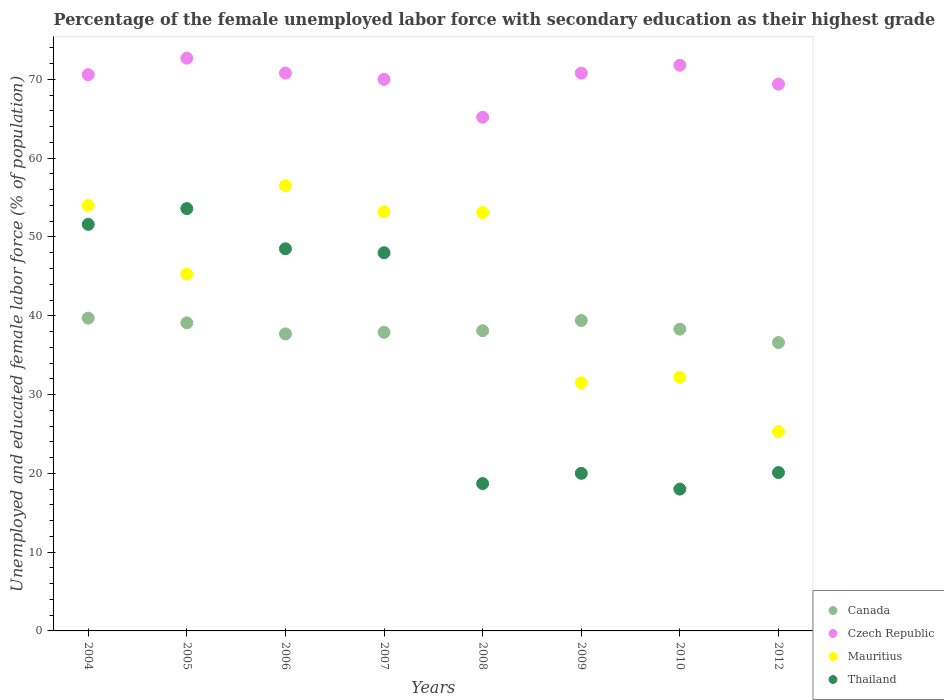How many different coloured dotlines are there?
Make the answer very short. 4. What is the percentage of the unemployed female labor force with secondary education in Canada in 2005?
Give a very brief answer. 39.1. Across all years, what is the maximum percentage of the unemployed female labor force with secondary education in Thailand?
Offer a very short reply. 53.6. Across all years, what is the minimum percentage of the unemployed female labor force with secondary education in Czech Republic?
Give a very brief answer. 65.2. What is the total percentage of the unemployed female labor force with secondary education in Czech Republic in the graph?
Keep it short and to the point. 561.3. What is the difference between the percentage of the unemployed female labor force with secondary education in Thailand in 2006 and that in 2009?
Provide a short and direct response. 28.5. What is the difference between the percentage of the unemployed female labor force with secondary education in Thailand in 2005 and the percentage of the unemployed female labor force with secondary education in Canada in 2008?
Your response must be concise. 15.5. What is the average percentage of the unemployed female labor force with secondary education in Mauritius per year?
Offer a very short reply. 43.89. In the year 2005, what is the difference between the percentage of the unemployed female labor force with secondary education in Mauritius and percentage of the unemployed female labor force with secondary education in Czech Republic?
Give a very brief answer. -27.4. In how many years, is the percentage of the unemployed female labor force with secondary education in Czech Republic greater than 66 %?
Ensure brevity in your answer.  7. What is the ratio of the percentage of the unemployed female labor force with secondary education in Czech Republic in 2004 to that in 2006?
Offer a very short reply. 1. Is the percentage of the unemployed female labor force with secondary education in Canada in 2008 less than that in 2009?
Provide a succinct answer. Yes. Is the difference between the percentage of the unemployed female labor force with secondary education in Mauritius in 2004 and 2006 greater than the difference between the percentage of the unemployed female labor force with secondary education in Czech Republic in 2004 and 2006?
Make the answer very short. No. What is the difference between the highest and the lowest percentage of the unemployed female labor force with secondary education in Czech Republic?
Provide a short and direct response. 7.5. Is it the case that in every year, the sum of the percentage of the unemployed female labor force with secondary education in Mauritius and percentage of the unemployed female labor force with secondary education in Thailand  is greater than the percentage of the unemployed female labor force with secondary education in Canada?
Ensure brevity in your answer.  Yes. Does the percentage of the unemployed female labor force with secondary education in Mauritius monotonically increase over the years?
Your answer should be very brief. No. What is the difference between two consecutive major ticks on the Y-axis?
Give a very brief answer. 10. Are the values on the major ticks of Y-axis written in scientific E-notation?
Keep it short and to the point. No. Does the graph contain any zero values?
Ensure brevity in your answer.  No. Does the graph contain grids?
Make the answer very short. No. Where does the legend appear in the graph?
Provide a succinct answer. Bottom right. How many legend labels are there?
Provide a short and direct response. 4. How are the legend labels stacked?
Offer a very short reply. Vertical. What is the title of the graph?
Ensure brevity in your answer.  Percentage of the female unemployed labor force with secondary education as their highest grade. What is the label or title of the Y-axis?
Ensure brevity in your answer.  Unemployed and educated female labor force (% of population). What is the Unemployed and educated female labor force (% of population) in Canada in 2004?
Provide a short and direct response. 39.7. What is the Unemployed and educated female labor force (% of population) of Czech Republic in 2004?
Your answer should be very brief. 70.6. What is the Unemployed and educated female labor force (% of population) in Thailand in 2004?
Your answer should be very brief. 51.6. What is the Unemployed and educated female labor force (% of population) in Canada in 2005?
Provide a short and direct response. 39.1. What is the Unemployed and educated female labor force (% of population) in Czech Republic in 2005?
Your answer should be very brief. 72.7. What is the Unemployed and educated female labor force (% of population) of Mauritius in 2005?
Offer a very short reply. 45.3. What is the Unemployed and educated female labor force (% of population) of Thailand in 2005?
Your answer should be compact. 53.6. What is the Unemployed and educated female labor force (% of population) in Canada in 2006?
Offer a very short reply. 37.7. What is the Unemployed and educated female labor force (% of population) of Czech Republic in 2006?
Make the answer very short. 70.8. What is the Unemployed and educated female labor force (% of population) of Mauritius in 2006?
Keep it short and to the point. 56.5. What is the Unemployed and educated female labor force (% of population) of Thailand in 2006?
Offer a very short reply. 48.5. What is the Unemployed and educated female labor force (% of population) of Canada in 2007?
Keep it short and to the point. 37.9. What is the Unemployed and educated female labor force (% of population) of Mauritius in 2007?
Provide a succinct answer. 53.2. What is the Unemployed and educated female labor force (% of population) of Thailand in 2007?
Keep it short and to the point. 48. What is the Unemployed and educated female labor force (% of population) in Canada in 2008?
Provide a short and direct response. 38.1. What is the Unemployed and educated female labor force (% of population) in Czech Republic in 2008?
Offer a terse response. 65.2. What is the Unemployed and educated female labor force (% of population) of Mauritius in 2008?
Ensure brevity in your answer.  53.1. What is the Unemployed and educated female labor force (% of population) in Thailand in 2008?
Ensure brevity in your answer.  18.7. What is the Unemployed and educated female labor force (% of population) in Canada in 2009?
Keep it short and to the point. 39.4. What is the Unemployed and educated female labor force (% of population) of Czech Republic in 2009?
Offer a very short reply. 70.8. What is the Unemployed and educated female labor force (% of population) of Mauritius in 2009?
Ensure brevity in your answer.  31.5. What is the Unemployed and educated female labor force (% of population) in Canada in 2010?
Provide a succinct answer. 38.3. What is the Unemployed and educated female labor force (% of population) of Czech Republic in 2010?
Make the answer very short. 71.8. What is the Unemployed and educated female labor force (% of population) of Mauritius in 2010?
Offer a terse response. 32.2. What is the Unemployed and educated female labor force (% of population) of Canada in 2012?
Your answer should be very brief. 36.6. What is the Unemployed and educated female labor force (% of population) of Czech Republic in 2012?
Ensure brevity in your answer.  69.4. What is the Unemployed and educated female labor force (% of population) in Mauritius in 2012?
Provide a short and direct response. 25.3. What is the Unemployed and educated female labor force (% of population) in Thailand in 2012?
Your answer should be compact. 20.1. Across all years, what is the maximum Unemployed and educated female labor force (% of population) of Canada?
Make the answer very short. 39.7. Across all years, what is the maximum Unemployed and educated female labor force (% of population) in Czech Republic?
Your answer should be very brief. 72.7. Across all years, what is the maximum Unemployed and educated female labor force (% of population) of Mauritius?
Offer a terse response. 56.5. Across all years, what is the maximum Unemployed and educated female labor force (% of population) of Thailand?
Your answer should be very brief. 53.6. Across all years, what is the minimum Unemployed and educated female labor force (% of population) in Canada?
Your answer should be compact. 36.6. Across all years, what is the minimum Unemployed and educated female labor force (% of population) of Czech Republic?
Provide a short and direct response. 65.2. Across all years, what is the minimum Unemployed and educated female labor force (% of population) in Mauritius?
Your response must be concise. 25.3. What is the total Unemployed and educated female labor force (% of population) of Canada in the graph?
Your answer should be compact. 306.8. What is the total Unemployed and educated female labor force (% of population) of Czech Republic in the graph?
Your answer should be very brief. 561.3. What is the total Unemployed and educated female labor force (% of population) in Mauritius in the graph?
Provide a short and direct response. 351.1. What is the total Unemployed and educated female labor force (% of population) in Thailand in the graph?
Keep it short and to the point. 278.5. What is the difference between the Unemployed and educated female labor force (% of population) in Czech Republic in 2004 and that in 2005?
Your answer should be compact. -2.1. What is the difference between the Unemployed and educated female labor force (% of population) of Mauritius in 2004 and that in 2005?
Your response must be concise. 8.7. What is the difference between the Unemployed and educated female labor force (% of population) of Canada in 2004 and that in 2006?
Ensure brevity in your answer.  2. What is the difference between the Unemployed and educated female labor force (% of population) in Mauritius in 2004 and that in 2006?
Provide a succinct answer. -2.5. What is the difference between the Unemployed and educated female labor force (% of population) in Czech Republic in 2004 and that in 2007?
Ensure brevity in your answer.  0.6. What is the difference between the Unemployed and educated female labor force (% of population) of Mauritius in 2004 and that in 2007?
Provide a succinct answer. 0.8. What is the difference between the Unemployed and educated female labor force (% of population) in Thailand in 2004 and that in 2007?
Give a very brief answer. 3.6. What is the difference between the Unemployed and educated female labor force (% of population) in Mauritius in 2004 and that in 2008?
Your answer should be very brief. 0.9. What is the difference between the Unemployed and educated female labor force (% of population) in Thailand in 2004 and that in 2008?
Make the answer very short. 32.9. What is the difference between the Unemployed and educated female labor force (% of population) in Czech Republic in 2004 and that in 2009?
Offer a very short reply. -0.2. What is the difference between the Unemployed and educated female labor force (% of population) in Mauritius in 2004 and that in 2009?
Offer a terse response. 22.5. What is the difference between the Unemployed and educated female labor force (% of population) of Thailand in 2004 and that in 2009?
Your response must be concise. 31.6. What is the difference between the Unemployed and educated female labor force (% of population) of Czech Republic in 2004 and that in 2010?
Your answer should be compact. -1.2. What is the difference between the Unemployed and educated female labor force (% of population) in Mauritius in 2004 and that in 2010?
Offer a very short reply. 21.8. What is the difference between the Unemployed and educated female labor force (% of population) of Thailand in 2004 and that in 2010?
Provide a succinct answer. 33.6. What is the difference between the Unemployed and educated female labor force (% of population) in Mauritius in 2004 and that in 2012?
Keep it short and to the point. 28.7. What is the difference between the Unemployed and educated female labor force (% of population) of Thailand in 2004 and that in 2012?
Your response must be concise. 31.5. What is the difference between the Unemployed and educated female labor force (% of population) in Canada in 2005 and that in 2006?
Your answer should be compact. 1.4. What is the difference between the Unemployed and educated female labor force (% of population) in Czech Republic in 2005 and that in 2006?
Provide a short and direct response. 1.9. What is the difference between the Unemployed and educated female labor force (% of population) of Thailand in 2005 and that in 2006?
Provide a succinct answer. 5.1. What is the difference between the Unemployed and educated female labor force (% of population) in Czech Republic in 2005 and that in 2007?
Keep it short and to the point. 2.7. What is the difference between the Unemployed and educated female labor force (% of population) in Czech Republic in 2005 and that in 2008?
Offer a terse response. 7.5. What is the difference between the Unemployed and educated female labor force (% of population) in Thailand in 2005 and that in 2008?
Make the answer very short. 34.9. What is the difference between the Unemployed and educated female labor force (% of population) of Czech Republic in 2005 and that in 2009?
Provide a succinct answer. 1.9. What is the difference between the Unemployed and educated female labor force (% of population) of Mauritius in 2005 and that in 2009?
Ensure brevity in your answer.  13.8. What is the difference between the Unemployed and educated female labor force (% of population) in Thailand in 2005 and that in 2009?
Offer a terse response. 33.6. What is the difference between the Unemployed and educated female labor force (% of population) of Czech Republic in 2005 and that in 2010?
Provide a succinct answer. 0.9. What is the difference between the Unemployed and educated female labor force (% of population) in Thailand in 2005 and that in 2010?
Provide a succinct answer. 35.6. What is the difference between the Unemployed and educated female labor force (% of population) in Czech Republic in 2005 and that in 2012?
Your answer should be very brief. 3.3. What is the difference between the Unemployed and educated female labor force (% of population) of Thailand in 2005 and that in 2012?
Offer a very short reply. 33.5. What is the difference between the Unemployed and educated female labor force (% of population) of Canada in 2006 and that in 2007?
Your answer should be compact. -0.2. What is the difference between the Unemployed and educated female labor force (% of population) of Thailand in 2006 and that in 2007?
Give a very brief answer. 0.5. What is the difference between the Unemployed and educated female labor force (% of population) in Thailand in 2006 and that in 2008?
Ensure brevity in your answer.  29.8. What is the difference between the Unemployed and educated female labor force (% of population) in Canada in 2006 and that in 2009?
Your answer should be compact. -1.7. What is the difference between the Unemployed and educated female labor force (% of population) in Mauritius in 2006 and that in 2009?
Provide a succinct answer. 25. What is the difference between the Unemployed and educated female labor force (% of population) in Czech Republic in 2006 and that in 2010?
Offer a terse response. -1. What is the difference between the Unemployed and educated female labor force (% of population) in Mauritius in 2006 and that in 2010?
Your answer should be very brief. 24.3. What is the difference between the Unemployed and educated female labor force (% of population) of Thailand in 2006 and that in 2010?
Make the answer very short. 30.5. What is the difference between the Unemployed and educated female labor force (% of population) in Canada in 2006 and that in 2012?
Offer a terse response. 1.1. What is the difference between the Unemployed and educated female labor force (% of population) of Mauritius in 2006 and that in 2012?
Provide a succinct answer. 31.2. What is the difference between the Unemployed and educated female labor force (% of population) in Thailand in 2006 and that in 2012?
Offer a very short reply. 28.4. What is the difference between the Unemployed and educated female labor force (% of population) in Czech Republic in 2007 and that in 2008?
Keep it short and to the point. 4.8. What is the difference between the Unemployed and educated female labor force (% of population) of Thailand in 2007 and that in 2008?
Offer a very short reply. 29.3. What is the difference between the Unemployed and educated female labor force (% of population) of Czech Republic in 2007 and that in 2009?
Give a very brief answer. -0.8. What is the difference between the Unemployed and educated female labor force (% of population) of Mauritius in 2007 and that in 2009?
Offer a very short reply. 21.7. What is the difference between the Unemployed and educated female labor force (% of population) of Thailand in 2007 and that in 2009?
Ensure brevity in your answer.  28. What is the difference between the Unemployed and educated female labor force (% of population) in Czech Republic in 2007 and that in 2010?
Your answer should be very brief. -1.8. What is the difference between the Unemployed and educated female labor force (% of population) in Mauritius in 2007 and that in 2010?
Offer a terse response. 21. What is the difference between the Unemployed and educated female labor force (% of population) of Canada in 2007 and that in 2012?
Your response must be concise. 1.3. What is the difference between the Unemployed and educated female labor force (% of population) of Mauritius in 2007 and that in 2012?
Your answer should be compact. 27.9. What is the difference between the Unemployed and educated female labor force (% of population) of Thailand in 2007 and that in 2012?
Make the answer very short. 27.9. What is the difference between the Unemployed and educated female labor force (% of population) in Mauritius in 2008 and that in 2009?
Provide a succinct answer. 21.6. What is the difference between the Unemployed and educated female labor force (% of population) in Thailand in 2008 and that in 2009?
Your answer should be compact. -1.3. What is the difference between the Unemployed and educated female labor force (% of population) in Canada in 2008 and that in 2010?
Ensure brevity in your answer.  -0.2. What is the difference between the Unemployed and educated female labor force (% of population) in Mauritius in 2008 and that in 2010?
Ensure brevity in your answer.  20.9. What is the difference between the Unemployed and educated female labor force (% of population) of Thailand in 2008 and that in 2010?
Ensure brevity in your answer.  0.7. What is the difference between the Unemployed and educated female labor force (% of population) of Czech Republic in 2008 and that in 2012?
Offer a terse response. -4.2. What is the difference between the Unemployed and educated female labor force (% of population) of Mauritius in 2008 and that in 2012?
Make the answer very short. 27.8. What is the difference between the Unemployed and educated female labor force (% of population) of Thailand in 2008 and that in 2012?
Offer a terse response. -1.4. What is the difference between the Unemployed and educated female labor force (% of population) of Czech Republic in 2009 and that in 2010?
Make the answer very short. -1. What is the difference between the Unemployed and educated female labor force (% of population) of Thailand in 2009 and that in 2010?
Provide a succinct answer. 2. What is the difference between the Unemployed and educated female labor force (% of population) of Czech Republic in 2010 and that in 2012?
Ensure brevity in your answer.  2.4. What is the difference between the Unemployed and educated female labor force (% of population) of Canada in 2004 and the Unemployed and educated female labor force (% of population) of Czech Republic in 2005?
Your answer should be very brief. -33. What is the difference between the Unemployed and educated female labor force (% of population) of Canada in 2004 and the Unemployed and educated female labor force (% of population) of Mauritius in 2005?
Keep it short and to the point. -5.6. What is the difference between the Unemployed and educated female labor force (% of population) of Canada in 2004 and the Unemployed and educated female labor force (% of population) of Thailand in 2005?
Provide a succinct answer. -13.9. What is the difference between the Unemployed and educated female labor force (% of population) of Czech Republic in 2004 and the Unemployed and educated female labor force (% of population) of Mauritius in 2005?
Give a very brief answer. 25.3. What is the difference between the Unemployed and educated female labor force (% of population) in Czech Republic in 2004 and the Unemployed and educated female labor force (% of population) in Thailand in 2005?
Give a very brief answer. 17. What is the difference between the Unemployed and educated female labor force (% of population) of Mauritius in 2004 and the Unemployed and educated female labor force (% of population) of Thailand in 2005?
Your response must be concise. 0.4. What is the difference between the Unemployed and educated female labor force (% of population) in Canada in 2004 and the Unemployed and educated female labor force (% of population) in Czech Republic in 2006?
Offer a very short reply. -31.1. What is the difference between the Unemployed and educated female labor force (% of population) in Canada in 2004 and the Unemployed and educated female labor force (% of population) in Mauritius in 2006?
Your answer should be compact. -16.8. What is the difference between the Unemployed and educated female labor force (% of population) of Czech Republic in 2004 and the Unemployed and educated female labor force (% of population) of Thailand in 2006?
Give a very brief answer. 22.1. What is the difference between the Unemployed and educated female labor force (% of population) in Canada in 2004 and the Unemployed and educated female labor force (% of population) in Czech Republic in 2007?
Your answer should be very brief. -30.3. What is the difference between the Unemployed and educated female labor force (% of population) in Canada in 2004 and the Unemployed and educated female labor force (% of population) in Mauritius in 2007?
Give a very brief answer. -13.5. What is the difference between the Unemployed and educated female labor force (% of population) in Canada in 2004 and the Unemployed and educated female labor force (% of population) in Thailand in 2007?
Your answer should be compact. -8.3. What is the difference between the Unemployed and educated female labor force (% of population) in Czech Republic in 2004 and the Unemployed and educated female labor force (% of population) in Thailand in 2007?
Make the answer very short. 22.6. What is the difference between the Unemployed and educated female labor force (% of population) in Mauritius in 2004 and the Unemployed and educated female labor force (% of population) in Thailand in 2007?
Offer a very short reply. 6. What is the difference between the Unemployed and educated female labor force (% of population) in Canada in 2004 and the Unemployed and educated female labor force (% of population) in Czech Republic in 2008?
Offer a very short reply. -25.5. What is the difference between the Unemployed and educated female labor force (% of population) of Canada in 2004 and the Unemployed and educated female labor force (% of population) of Mauritius in 2008?
Your answer should be compact. -13.4. What is the difference between the Unemployed and educated female labor force (% of population) in Czech Republic in 2004 and the Unemployed and educated female labor force (% of population) in Mauritius in 2008?
Your answer should be very brief. 17.5. What is the difference between the Unemployed and educated female labor force (% of population) of Czech Republic in 2004 and the Unemployed and educated female labor force (% of population) of Thailand in 2008?
Offer a very short reply. 51.9. What is the difference between the Unemployed and educated female labor force (% of population) in Mauritius in 2004 and the Unemployed and educated female labor force (% of population) in Thailand in 2008?
Your response must be concise. 35.3. What is the difference between the Unemployed and educated female labor force (% of population) in Canada in 2004 and the Unemployed and educated female labor force (% of population) in Czech Republic in 2009?
Provide a succinct answer. -31.1. What is the difference between the Unemployed and educated female labor force (% of population) in Canada in 2004 and the Unemployed and educated female labor force (% of population) in Mauritius in 2009?
Your answer should be compact. 8.2. What is the difference between the Unemployed and educated female labor force (% of population) in Czech Republic in 2004 and the Unemployed and educated female labor force (% of population) in Mauritius in 2009?
Give a very brief answer. 39.1. What is the difference between the Unemployed and educated female labor force (% of population) in Czech Republic in 2004 and the Unemployed and educated female labor force (% of population) in Thailand in 2009?
Your response must be concise. 50.6. What is the difference between the Unemployed and educated female labor force (% of population) in Mauritius in 2004 and the Unemployed and educated female labor force (% of population) in Thailand in 2009?
Make the answer very short. 34. What is the difference between the Unemployed and educated female labor force (% of population) of Canada in 2004 and the Unemployed and educated female labor force (% of population) of Czech Republic in 2010?
Provide a short and direct response. -32.1. What is the difference between the Unemployed and educated female labor force (% of population) of Canada in 2004 and the Unemployed and educated female labor force (% of population) of Thailand in 2010?
Ensure brevity in your answer.  21.7. What is the difference between the Unemployed and educated female labor force (% of population) of Czech Republic in 2004 and the Unemployed and educated female labor force (% of population) of Mauritius in 2010?
Your answer should be very brief. 38.4. What is the difference between the Unemployed and educated female labor force (% of population) in Czech Republic in 2004 and the Unemployed and educated female labor force (% of population) in Thailand in 2010?
Provide a succinct answer. 52.6. What is the difference between the Unemployed and educated female labor force (% of population) of Mauritius in 2004 and the Unemployed and educated female labor force (% of population) of Thailand in 2010?
Ensure brevity in your answer.  36. What is the difference between the Unemployed and educated female labor force (% of population) of Canada in 2004 and the Unemployed and educated female labor force (% of population) of Czech Republic in 2012?
Your answer should be compact. -29.7. What is the difference between the Unemployed and educated female labor force (% of population) in Canada in 2004 and the Unemployed and educated female labor force (% of population) in Thailand in 2012?
Give a very brief answer. 19.6. What is the difference between the Unemployed and educated female labor force (% of population) of Czech Republic in 2004 and the Unemployed and educated female labor force (% of population) of Mauritius in 2012?
Your answer should be very brief. 45.3. What is the difference between the Unemployed and educated female labor force (% of population) of Czech Republic in 2004 and the Unemployed and educated female labor force (% of population) of Thailand in 2012?
Provide a short and direct response. 50.5. What is the difference between the Unemployed and educated female labor force (% of population) in Mauritius in 2004 and the Unemployed and educated female labor force (% of population) in Thailand in 2012?
Offer a very short reply. 33.9. What is the difference between the Unemployed and educated female labor force (% of population) of Canada in 2005 and the Unemployed and educated female labor force (% of population) of Czech Republic in 2006?
Offer a terse response. -31.7. What is the difference between the Unemployed and educated female labor force (% of population) of Canada in 2005 and the Unemployed and educated female labor force (% of population) of Mauritius in 2006?
Give a very brief answer. -17.4. What is the difference between the Unemployed and educated female labor force (% of population) in Canada in 2005 and the Unemployed and educated female labor force (% of population) in Thailand in 2006?
Give a very brief answer. -9.4. What is the difference between the Unemployed and educated female labor force (% of population) in Czech Republic in 2005 and the Unemployed and educated female labor force (% of population) in Thailand in 2006?
Your answer should be very brief. 24.2. What is the difference between the Unemployed and educated female labor force (% of population) in Mauritius in 2005 and the Unemployed and educated female labor force (% of population) in Thailand in 2006?
Offer a terse response. -3.2. What is the difference between the Unemployed and educated female labor force (% of population) in Canada in 2005 and the Unemployed and educated female labor force (% of population) in Czech Republic in 2007?
Keep it short and to the point. -30.9. What is the difference between the Unemployed and educated female labor force (% of population) of Canada in 2005 and the Unemployed and educated female labor force (% of population) of Mauritius in 2007?
Offer a very short reply. -14.1. What is the difference between the Unemployed and educated female labor force (% of population) of Canada in 2005 and the Unemployed and educated female labor force (% of population) of Thailand in 2007?
Your answer should be compact. -8.9. What is the difference between the Unemployed and educated female labor force (% of population) of Czech Republic in 2005 and the Unemployed and educated female labor force (% of population) of Mauritius in 2007?
Give a very brief answer. 19.5. What is the difference between the Unemployed and educated female labor force (% of population) in Czech Republic in 2005 and the Unemployed and educated female labor force (% of population) in Thailand in 2007?
Make the answer very short. 24.7. What is the difference between the Unemployed and educated female labor force (% of population) in Canada in 2005 and the Unemployed and educated female labor force (% of population) in Czech Republic in 2008?
Give a very brief answer. -26.1. What is the difference between the Unemployed and educated female labor force (% of population) of Canada in 2005 and the Unemployed and educated female labor force (% of population) of Thailand in 2008?
Offer a terse response. 20.4. What is the difference between the Unemployed and educated female labor force (% of population) of Czech Republic in 2005 and the Unemployed and educated female labor force (% of population) of Mauritius in 2008?
Your answer should be very brief. 19.6. What is the difference between the Unemployed and educated female labor force (% of population) of Czech Republic in 2005 and the Unemployed and educated female labor force (% of population) of Thailand in 2008?
Keep it short and to the point. 54. What is the difference between the Unemployed and educated female labor force (% of population) of Mauritius in 2005 and the Unemployed and educated female labor force (% of population) of Thailand in 2008?
Provide a succinct answer. 26.6. What is the difference between the Unemployed and educated female labor force (% of population) in Canada in 2005 and the Unemployed and educated female labor force (% of population) in Czech Republic in 2009?
Your answer should be very brief. -31.7. What is the difference between the Unemployed and educated female labor force (% of population) of Canada in 2005 and the Unemployed and educated female labor force (% of population) of Mauritius in 2009?
Your answer should be very brief. 7.6. What is the difference between the Unemployed and educated female labor force (% of population) in Czech Republic in 2005 and the Unemployed and educated female labor force (% of population) in Mauritius in 2009?
Your answer should be compact. 41.2. What is the difference between the Unemployed and educated female labor force (% of population) of Czech Republic in 2005 and the Unemployed and educated female labor force (% of population) of Thailand in 2009?
Your answer should be compact. 52.7. What is the difference between the Unemployed and educated female labor force (% of population) in Mauritius in 2005 and the Unemployed and educated female labor force (% of population) in Thailand in 2009?
Your answer should be very brief. 25.3. What is the difference between the Unemployed and educated female labor force (% of population) in Canada in 2005 and the Unemployed and educated female labor force (% of population) in Czech Republic in 2010?
Ensure brevity in your answer.  -32.7. What is the difference between the Unemployed and educated female labor force (% of population) of Canada in 2005 and the Unemployed and educated female labor force (% of population) of Thailand in 2010?
Give a very brief answer. 21.1. What is the difference between the Unemployed and educated female labor force (% of population) of Czech Republic in 2005 and the Unemployed and educated female labor force (% of population) of Mauritius in 2010?
Offer a very short reply. 40.5. What is the difference between the Unemployed and educated female labor force (% of population) in Czech Republic in 2005 and the Unemployed and educated female labor force (% of population) in Thailand in 2010?
Make the answer very short. 54.7. What is the difference between the Unemployed and educated female labor force (% of population) in Mauritius in 2005 and the Unemployed and educated female labor force (% of population) in Thailand in 2010?
Give a very brief answer. 27.3. What is the difference between the Unemployed and educated female labor force (% of population) of Canada in 2005 and the Unemployed and educated female labor force (% of population) of Czech Republic in 2012?
Offer a very short reply. -30.3. What is the difference between the Unemployed and educated female labor force (% of population) of Canada in 2005 and the Unemployed and educated female labor force (% of population) of Thailand in 2012?
Ensure brevity in your answer.  19. What is the difference between the Unemployed and educated female labor force (% of population) of Czech Republic in 2005 and the Unemployed and educated female labor force (% of population) of Mauritius in 2012?
Give a very brief answer. 47.4. What is the difference between the Unemployed and educated female labor force (% of population) in Czech Republic in 2005 and the Unemployed and educated female labor force (% of population) in Thailand in 2012?
Provide a short and direct response. 52.6. What is the difference between the Unemployed and educated female labor force (% of population) in Mauritius in 2005 and the Unemployed and educated female labor force (% of population) in Thailand in 2012?
Offer a terse response. 25.2. What is the difference between the Unemployed and educated female labor force (% of population) in Canada in 2006 and the Unemployed and educated female labor force (% of population) in Czech Republic in 2007?
Ensure brevity in your answer.  -32.3. What is the difference between the Unemployed and educated female labor force (% of population) in Canada in 2006 and the Unemployed and educated female labor force (% of population) in Mauritius in 2007?
Your answer should be very brief. -15.5. What is the difference between the Unemployed and educated female labor force (% of population) in Czech Republic in 2006 and the Unemployed and educated female labor force (% of population) in Thailand in 2007?
Your answer should be very brief. 22.8. What is the difference between the Unemployed and educated female labor force (% of population) of Mauritius in 2006 and the Unemployed and educated female labor force (% of population) of Thailand in 2007?
Your answer should be very brief. 8.5. What is the difference between the Unemployed and educated female labor force (% of population) in Canada in 2006 and the Unemployed and educated female labor force (% of population) in Czech Republic in 2008?
Offer a terse response. -27.5. What is the difference between the Unemployed and educated female labor force (% of population) of Canada in 2006 and the Unemployed and educated female labor force (% of population) of Mauritius in 2008?
Ensure brevity in your answer.  -15.4. What is the difference between the Unemployed and educated female labor force (% of population) in Canada in 2006 and the Unemployed and educated female labor force (% of population) in Thailand in 2008?
Offer a terse response. 19. What is the difference between the Unemployed and educated female labor force (% of population) in Czech Republic in 2006 and the Unemployed and educated female labor force (% of population) in Mauritius in 2008?
Keep it short and to the point. 17.7. What is the difference between the Unemployed and educated female labor force (% of population) in Czech Republic in 2006 and the Unemployed and educated female labor force (% of population) in Thailand in 2008?
Offer a very short reply. 52.1. What is the difference between the Unemployed and educated female labor force (% of population) of Mauritius in 2006 and the Unemployed and educated female labor force (% of population) of Thailand in 2008?
Provide a short and direct response. 37.8. What is the difference between the Unemployed and educated female labor force (% of population) of Canada in 2006 and the Unemployed and educated female labor force (% of population) of Czech Republic in 2009?
Keep it short and to the point. -33.1. What is the difference between the Unemployed and educated female labor force (% of population) in Canada in 2006 and the Unemployed and educated female labor force (% of population) in Mauritius in 2009?
Make the answer very short. 6.2. What is the difference between the Unemployed and educated female labor force (% of population) in Czech Republic in 2006 and the Unemployed and educated female labor force (% of population) in Mauritius in 2009?
Your answer should be compact. 39.3. What is the difference between the Unemployed and educated female labor force (% of population) in Czech Republic in 2006 and the Unemployed and educated female labor force (% of population) in Thailand in 2009?
Give a very brief answer. 50.8. What is the difference between the Unemployed and educated female labor force (% of population) of Mauritius in 2006 and the Unemployed and educated female labor force (% of population) of Thailand in 2009?
Offer a terse response. 36.5. What is the difference between the Unemployed and educated female labor force (% of population) of Canada in 2006 and the Unemployed and educated female labor force (% of population) of Czech Republic in 2010?
Offer a terse response. -34.1. What is the difference between the Unemployed and educated female labor force (% of population) in Canada in 2006 and the Unemployed and educated female labor force (% of population) in Mauritius in 2010?
Give a very brief answer. 5.5. What is the difference between the Unemployed and educated female labor force (% of population) of Canada in 2006 and the Unemployed and educated female labor force (% of population) of Thailand in 2010?
Your response must be concise. 19.7. What is the difference between the Unemployed and educated female labor force (% of population) in Czech Republic in 2006 and the Unemployed and educated female labor force (% of population) in Mauritius in 2010?
Offer a terse response. 38.6. What is the difference between the Unemployed and educated female labor force (% of population) in Czech Republic in 2006 and the Unemployed and educated female labor force (% of population) in Thailand in 2010?
Your response must be concise. 52.8. What is the difference between the Unemployed and educated female labor force (% of population) in Mauritius in 2006 and the Unemployed and educated female labor force (% of population) in Thailand in 2010?
Keep it short and to the point. 38.5. What is the difference between the Unemployed and educated female labor force (% of population) in Canada in 2006 and the Unemployed and educated female labor force (% of population) in Czech Republic in 2012?
Your answer should be compact. -31.7. What is the difference between the Unemployed and educated female labor force (% of population) in Canada in 2006 and the Unemployed and educated female labor force (% of population) in Thailand in 2012?
Make the answer very short. 17.6. What is the difference between the Unemployed and educated female labor force (% of population) in Czech Republic in 2006 and the Unemployed and educated female labor force (% of population) in Mauritius in 2012?
Your answer should be very brief. 45.5. What is the difference between the Unemployed and educated female labor force (% of population) in Czech Republic in 2006 and the Unemployed and educated female labor force (% of population) in Thailand in 2012?
Offer a terse response. 50.7. What is the difference between the Unemployed and educated female labor force (% of population) of Mauritius in 2006 and the Unemployed and educated female labor force (% of population) of Thailand in 2012?
Provide a short and direct response. 36.4. What is the difference between the Unemployed and educated female labor force (% of population) in Canada in 2007 and the Unemployed and educated female labor force (% of population) in Czech Republic in 2008?
Provide a succinct answer. -27.3. What is the difference between the Unemployed and educated female labor force (% of population) in Canada in 2007 and the Unemployed and educated female labor force (% of population) in Mauritius in 2008?
Your answer should be very brief. -15.2. What is the difference between the Unemployed and educated female labor force (% of population) of Czech Republic in 2007 and the Unemployed and educated female labor force (% of population) of Thailand in 2008?
Your response must be concise. 51.3. What is the difference between the Unemployed and educated female labor force (% of population) of Mauritius in 2007 and the Unemployed and educated female labor force (% of population) of Thailand in 2008?
Give a very brief answer. 34.5. What is the difference between the Unemployed and educated female labor force (% of population) in Canada in 2007 and the Unemployed and educated female labor force (% of population) in Czech Republic in 2009?
Make the answer very short. -32.9. What is the difference between the Unemployed and educated female labor force (% of population) of Canada in 2007 and the Unemployed and educated female labor force (% of population) of Mauritius in 2009?
Offer a very short reply. 6.4. What is the difference between the Unemployed and educated female labor force (% of population) of Canada in 2007 and the Unemployed and educated female labor force (% of population) of Thailand in 2009?
Provide a short and direct response. 17.9. What is the difference between the Unemployed and educated female labor force (% of population) in Czech Republic in 2007 and the Unemployed and educated female labor force (% of population) in Mauritius in 2009?
Provide a short and direct response. 38.5. What is the difference between the Unemployed and educated female labor force (% of population) of Mauritius in 2007 and the Unemployed and educated female labor force (% of population) of Thailand in 2009?
Offer a terse response. 33.2. What is the difference between the Unemployed and educated female labor force (% of population) of Canada in 2007 and the Unemployed and educated female labor force (% of population) of Czech Republic in 2010?
Keep it short and to the point. -33.9. What is the difference between the Unemployed and educated female labor force (% of population) of Canada in 2007 and the Unemployed and educated female labor force (% of population) of Thailand in 2010?
Provide a succinct answer. 19.9. What is the difference between the Unemployed and educated female labor force (% of population) of Czech Republic in 2007 and the Unemployed and educated female labor force (% of population) of Mauritius in 2010?
Make the answer very short. 37.8. What is the difference between the Unemployed and educated female labor force (% of population) of Czech Republic in 2007 and the Unemployed and educated female labor force (% of population) of Thailand in 2010?
Offer a very short reply. 52. What is the difference between the Unemployed and educated female labor force (% of population) in Mauritius in 2007 and the Unemployed and educated female labor force (% of population) in Thailand in 2010?
Your answer should be compact. 35.2. What is the difference between the Unemployed and educated female labor force (% of population) of Canada in 2007 and the Unemployed and educated female labor force (% of population) of Czech Republic in 2012?
Keep it short and to the point. -31.5. What is the difference between the Unemployed and educated female labor force (% of population) of Czech Republic in 2007 and the Unemployed and educated female labor force (% of population) of Mauritius in 2012?
Offer a terse response. 44.7. What is the difference between the Unemployed and educated female labor force (% of population) of Czech Republic in 2007 and the Unemployed and educated female labor force (% of population) of Thailand in 2012?
Provide a short and direct response. 49.9. What is the difference between the Unemployed and educated female labor force (% of population) of Mauritius in 2007 and the Unemployed and educated female labor force (% of population) of Thailand in 2012?
Keep it short and to the point. 33.1. What is the difference between the Unemployed and educated female labor force (% of population) of Canada in 2008 and the Unemployed and educated female labor force (% of population) of Czech Republic in 2009?
Offer a very short reply. -32.7. What is the difference between the Unemployed and educated female labor force (% of population) of Canada in 2008 and the Unemployed and educated female labor force (% of population) of Thailand in 2009?
Ensure brevity in your answer.  18.1. What is the difference between the Unemployed and educated female labor force (% of population) in Czech Republic in 2008 and the Unemployed and educated female labor force (% of population) in Mauritius in 2009?
Offer a terse response. 33.7. What is the difference between the Unemployed and educated female labor force (% of population) of Czech Republic in 2008 and the Unemployed and educated female labor force (% of population) of Thailand in 2009?
Make the answer very short. 45.2. What is the difference between the Unemployed and educated female labor force (% of population) of Mauritius in 2008 and the Unemployed and educated female labor force (% of population) of Thailand in 2009?
Offer a very short reply. 33.1. What is the difference between the Unemployed and educated female labor force (% of population) in Canada in 2008 and the Unemployed and educated female labor force (% of population) in Czech Republic in 2010?
Ensure brevity in your answer.  -33.7. What is the difference between the Unemployed and educated female labor force (% of population) of Canada in 2008 and the Unemployed and educated female labor force (% of population) of Thailand in 2010?
Your response must be concise. 20.1. What is the difference between the Unemployed and educated female labor force (% of population) in Czech Republic in 2008 and the Unemployed and educated female labor force (% of population) in Thailand in 2010?
Offer a very short reply. 47.2. What is the difference between the Unemployed and educated female labor force (% of population) in Mauritius in 2008 and the Unemployed and educated female labor force (% of population) in Thailand in 2010?
Offer a very short reply. 35.1. What is the difference between the Unemployed and educated female labor force (% of population) in Canada in 2008 and the Unemployed and educated female labor force (% of population) in Czech Republic in 2012?
Your answer should be compact. -31.3. What is the difference between the Unemployed and educated female labor force (% of population) in Canada in 2008 and the Unemployed and educated female labor force (% of population) in Thailand in 2012?
Offer a very short reply. 18. What is the difference between the Unemployed and educated female labor force (% of population) in Czech Republic in 2008 and the Unemployed and educated female labor force (% of population) in Mauritius in 2012?
Provide a short and direct response. 39.9. What is the difference between the Unemployed and educated female labor force (% of population) in Czech Republic in 2008 and the Unemployed and educated female labor force (% of population) in Thailand in 2012?
Your answer should be compact. 45.1. What is the difference between the Unemployed and educated female labor force (% of population) in Mauritius in 2008 and the Unemployed and educated female labor force (% of population) in Thailand in 2012?
Keep it short and to the point. 33. What is the difference between the Unemployed and educated female labor force (% of population) of Canada in 2009 and the Unemployed and educated female labor force (% of population) of Czech Republic in 2010?
Offer a terse response. -32.4. What is the difference between the Unemployed and educated female labor force (% of population) of Canada in 2009 and the Unemployed and educated female labor force (% of population) of Mauritius in 2010?
Provide a succinct answer. 7.2. What is the difference between the Unemployed and educated female labor force (% of population) in Canada in 2009 and the Unemployed and educated female labor force (% of population) in Thailand in 2010?
Offer a very short reply. 21.4. What is the difference between the Unemployed and educated female labor force (% of population) in Czech Republic in 2009 and the Unemployed and educated female labor force (% of population) in Mauritius in 2010?
Your response must be concise. 38.6. What is the difference between the Unemployed and educated female labor force (% of population) in Czech Republic in 2009 and the Unemployed and educated female labor force (% of population) in Thailand in 2010?
Your answer should be very brief. 52.8. What is the difference between the Unemployed and educated female labor force (% of population) in Canada in 2009 and the Unemployed and educated female labor force (% of population) in Czech Republic in 2012?
Provide a short and direct response. -30. What is the difference between the Unemployed and educated female labor force (% of population) in Canada in 2009 and the Unemployed and educated female labor force (% of population) in Thailand in 2012?
Give a very brief answer. 19.3. What is the difference between the Unemployed and educated female labor force (% of population) in Czech Republic in 2009 and the Unemployed and educated female labor force (% of population) in Mauritius in 2012?
Make the answer very short. 45.5. What is the difference between the Unemployed and educated female labor force (% of population) in Czech Republic in 2009 and the Unemployed and educated female labor force (% of population) in Thailand in 2012?
Your response must be concise. 50.7. What is the difference between the Unemployed and educated female labor force (% of population) in Mauritius in 2009 and the Unemployed and educated female labor force (% of population) in Thailand in 2012?
Make the answer very short. 11.4. What is the difference between the Unemployed and educated female labor force (% of population) of Canada in 2010 and the Unemployed and educated female labor force (% of population) of Czech Republic in 2012?
Give a very brief answer. -31.1. What is the difference between the Unemployed and educated female labor force (% of population) of Canada in 2010 and the Unemployed and educated female labor force (% of population) of Mauritius in 2012?
Your answer should be compact. 13. What is the difference between the Unemployed and educated female labor force (% of population) in Canada in 2010 and the Unemployed and educated female labor force (% of population) in Thailand in 2012?
Your answer should be compact. 18.2. What is the difference between the Unemployed and educated female labor force (% of population) of Czech Republic in 2010 and the Unemployed and educated female labor force (% of population) of Mauritius in 2012?
Offer a terse response. 46.5. What is the difference between the Unemployed and educated female labor force (% of population) of Czech Republic in 2010 and the Unemployed and educated female labor force (% of population) of Thailand in 2012?
Provide a succinct answer. 51.7. What is the average Unemployed and educated female labor force (% of population) of Canada per year?
Keep it short and to the point. 38.35. What is the average Unemployed and educated female labor force (% of population) in Czech Republic per year?
Your response must be concise. 70.16. What is the average Unemployed and educated female labor force (% of population) in Mauritius per year?
Keep it short and to the point. 43.89. What is the average Unemployed and educated female labor force (% of population) of Thailand per year?
Make the answer very short. 34.81. In the year 2004, what is the difference between the Unemployed and educated female labor force (% of population) of Canada and Unemployed and educated female labor force (% of population) of Czech Republic?
Your response must be concise. -30.9. In the year 2004, what is the difference between the Unemployed and educated female labor force (% of population) of Canada and Unemployed and educated female labor force (% of population) of Mauritius?
Your response must be concise. -14.3. In the year 2004, what is the difference between the Unemployed and educated female labor force (% of population) in Czech Republic and Unemployed and educated female labor force (% of population) in Mauritius?
Provide a succinct answer. 16.6. In the year 2004, what is the difference between the Unemployed and educated female labor force (% of population) in Mauritius and Unemployed and educated female labor force (% of population) in Thailand?
Make the answer very short. 2.4. In the year 2005, what is the difference between the Unemployed and educated female labor force (% of population) of Canada and Unemployed and educated female labor force (% of population) of Czech Republic?
Provide a succinct answer. -33.6. In the year 2005, what is the difference between the Unemployed and educated female labor force (% of population) in Canada and Unemployed and educated female labor force (% of population) in Thailand?
Make the answer very short. -14.5. In the year 2005, what is the difference between the Unemployed and educated female labor force (% of population) in Czech Republic and Unemployed and educated female labor force (% of population) in Mauritius?
Make the answer very short. 27.4. In the year 2005, what is the difference between the Unemployed and educated female labor force (% of population) in Czech Republic and Unemployed and educated female labor force (% of population) in Thailand?
Keep it short and to the point. 19.1. In the year 2005, what is the difference between the Unemployed and educated female labor force (% of population) of Mauritius and Unemployed and educated female labor force (% of population) of Thailand?
Offer a very short reply. -8.3. In the year 2006, what is the difference between the Unemployed and educated female labor force (% of population) in Canada and Unemployed and educated female labor force (% of population) in Czech Republic?
Your answer should be very brief. -33.1. In the year 2006, what is the difference between the Unemployed and educated female labor force (% of population) in Canada and Unemployed and educated female labor force (% of population) in Mauritius?
Give a very brief answer. -18.8. In the year 2006, what is the difference between the Unemployed and educated female labor force (% of population) of Canada and Unemployed and educated female labor force (% of population) of Thailand?
Provide a short and direct response. -10.8. In the year 2006, what is the difference between the Unemployed and educated female labor force (% of population) in Czech Republic and Unemployed and educated female labor force (% of population) in Thailand?
Make the answer very short. 22.3. In the year 2007, what is the difference between the Unemployed and educated female labor force (% of population) of Canada and Unemployed and educated female labor force (% of population) of Czech Republic?
Ensure brevity in your answer.  -32.1. In the year 2007, what is the difference between the Unemployed and educated female labor force (% of population) in Canada and Unemployed and educated female labor force (% of population) in Mauritius?
Your answer should be very brief. -15.3. In the year 2007, what is the difference between the Unemployed and educated female labor force (% of population) of Canada and Unemployed and educated female labor force (% of population) of Thailand?
Keep it short and to the point. -10.1. In the year 2007, what is the difference between the Unemployed and educated female labor force (% of population) in Mauritius and Unemployed and educated female labor force (% of population) in Thailand?
Offer a very short reply. 5.2. In the year 2008, what is the difference between the Unemployed and educated female labor force (% of population) in Canada and Unemployed and educated female labor force (% of population) in Czech Republic?
Provide a succinct answer. -27.1. In the year 2008, what is the difference between the Unemployed and educated female labor force (% of population) in Canada and Unemployed and educated female labor force (% of population) in Mauritius?
Make the answer very short. -15. In the year 2008, what is the difference between the Unemployed and educated female labor force (% of population) in Canada and Unemployed and educated female labor force (% of population) in Thailand?
Give a very brief answer. 19.4. In the year 2008, what is the difference between the Unemployed and educated female labor force (% of population) in Czech Republic and Unemployed and educated female labor force (% of population) in Thailand?
Give a very brief answer. 46.5. In the year 2008, what is the difference between the Unemployed and educated female labor force (% of population) in Mauritius and Unemployed and educated female labor force (% of population) in Thailand?
Give a very brief answer. 34.4. In the year 2009, what is the difference between the Unemployed and educated female labor force (% of population) in Canada and Unemployed and educated female labor force (% of population) in Czech Republic?
Your response must be concise. -31.4. In the year 2009, what is the difference between the Unemployed and educated female labor force (% of population) of Czech Republic and Unemployed and educated female labor force (% of population) of Mauritius?
Ensure brevity in your answer.  39.3. In the year 2009, what is the difference between the Unemployed and educated female labor force (% of population) in Czech Republic and Unemployed and educated female labor force (% of population) in Thailand?
Offer a very short reply. 50.8. In the year 2009, what is the difference between the Unemployed and educated female labor force (% of population) in Mauritius and Unemployed and educated female labor force (% of population) in Thailand?
Offer a very short reply. 11.5. In the year 2010, what is the difference between the Unemployed and educated female labor force (% of population) of Canada and Unemployed and educated female labor force (% of population) of Czech Republic?
Ensure brevity in your answer.  -33.5. In the year 2010, what is the difference between the Unemployed and educated female labor force (% of population) of Canada and Unemployed and educated female labor force (% of population) of Mauritius?
Give a very brief answer. 6.1. In the year 2010, what is the difference between the Unemployed and educated female labor force (% of population) of Canada and Unemployed and educated female labor force (% of population) of Thailand?
Ensure brevity in your answer.  20.3. In the year 2010, what is the difference between the Unemployed and educated female labor force (% of population) of Czech Republic and Unemployed and educated female labor force (% of population) of Mauritius?
Make the answer very short. 39.6. In the year 2010, what is the difference between the Unemployed and educated female labor force (% of population) of Czech Republic and Unemployed and educated female labor force (% of population) of Thailand?
Your response must be concise. 53.8. In the year 2010, what is the difference between the Unemployed and educated female labor force (% of population) in Mauritius and Unemployed and educated female labor force (% of population) in Thailand?
Your answer should be very brief. 14.2. In the year 2012, what is the difference between the Unemployed and educated female labor force (% of population) of Canada and Unemployed and educated female labor force (% of population) of Czech Republic?
Your answer should be compact. -32.8. In the year 2012, what is the difference between the Unemployed and educated female labor force (% of population) of Canada and Unemployed and educated female labor force (% of population) of Mauritius?
Your answer should be very brief. 11.3. In the year 2012, what is the difference between the Unemployed and educated female labor force (% of population) in Canada and Unemployed and educated female labor force (% of population) in Thailand?
Offer a terse response. 16.5. In the year 2012, what is the difference between the Unemployed and educated female labor force (% of population) in Czech Republic and Unemployed and educated female labor force (% of population) in Mauritius?
Give a very brief answer. 44.1. In the year 2012, what is the difference between the Unemployed and educated female labor force (% of population) in Czech Republic and Unemployed and educated female labor force (% of population) in Thailand?
Provide a succinct answer. 49.3. What is the ratio of the Unemployed and educated female labor force (% of population) of Canada in 2004 to that in 2005?
Your response must be concise. 1.02. What is the ratio of the Unemployed and educated female labor force (% of population) in Czech Republic in 2004 to that in 2005?
Your response must be concise. 0.97. What is the ratio of the Unemployed and educated female labor force (% of population) in Mauritius in 2004 to that in 2005?
Give a very brief answer. 1.19. What is the ratio of the Unemployed and educated female labor force (% of population) in Thailand in 2004 to that in 2005?
Provide a short and direct response. 0.96. What is the ratio of the Unemployed and educated female labor force (% of population) in Canada in 2004 to that in 2006?
Your answer should be very brief. 1.05. What is the ratio of the Unemployed and educated female labor force (% of population) of Czech Republic in 2004 to that in 2006?
Your answer should be compact. 1. What is the ratio of the Unemployed and educated female labor force (% of population) of Mauritius in 2004 to that in 2006?
Your answer should be very brief. 0.96. What is the ratio of the Unemployed and educated female labor force (% of population) of Thailand in 2004 to that in 2006?
Provide a short and direct response. 1.06. What is the ratio of the Unemployed and educated female labor force (% of population) of Canada in 2004 to that in 2007?
Provide a succinct answer. 1.05. What is the ratio of the Unemployed and educated female labor force (% of population) in Czech Republic in 2004 to that in 2007?
Your answer should be very brief. 1.01. What is the ratio of the Unemployed and educated female labor force (% of population) of Mauritius in 2004 to that in 2007?
Your answer should be compact. 1.01. What is the ratio of the Unemployed and educated female labor force (% of population) in Thailand in 2004 to that in 2007?
Ensure brevity in your answer.  1.07. What is the ratio of the Unemployed and educated female labor force (% of population) in Canada in 2004 to that in 2008?
Offer a terse response. 1.04. What is the ratio of the Unemployed and educated female labor force (% of population) in Czech Republic in 2004 to that in 2008?
Your answer should be very brief. 1.08. What is the ratio of the Unemployed and educated female labor force (% of population) of Mauritius in 2004 to that in 2008?
Give a very brief answer. 1.02. What is the ratio of the Unemployed and educated female labor force (% of population) of Thailand in 2004 to that in 2008?
Offer a very short reply. 2.76. What is the ratio of the Unemployed and educated female labor force (% of population) in Canada in 2004 to that in 2009?
Ensure brevity in your answer.  1.01. What is the ratio of the Unemployed and educated female labor force (% of population) of Mauritius in 2004 to that in 2009?
Your answer should be compact. 1.71. What is the ratio of the Unemployed and educated female labor force (% of population) of Thailand in 2004 to that in 2009?
Give a very brief answer. 2.58. What is the ratio of the Unemployed and educated female labor force (% of population) of Canada in 2004 to that in 2010?
Provide a succinct answer. 1.04. What is the ratio of the Unemployed and educated female labor force (% of population) in Czech Republic in 2004 to that in 2010?
Provide a succinct answer. 0.98. What is the ratio of the Unemployed and educated female labor force (% of population) in Mauritius in 2004 to that in 2010?
Offer a terse response. 1.68. What is the ratio of the Unemployed and educated female labor force (% of population) in Thailand in 2004 to that in 2010?
Provide a short and direct response. 2.87. What is the ratio of the Unemployed and educated female labor force (% of population) of Canada in 2004 to that in 2012?
Offer a terse response. 1.08. What is the ratio of the Unemployed and educated female labor force (% of population) of Czech Republic in 2004 to that in 2012?
Offer a very short reply. 1.02. What is the ratio of the Unemployed and educated female labor force (% of population) of Mauritius in 2004 to that in 2012?
Ensure brevity in your answer.  2.13. What is the ratio of the Unemployed and educated female labor force (% of population) of Thailand in 2004 to that in 2012?
Keep it short and to the point. 2.57. What is the ratio of the Unemployed and educated female labor force (% of population) in Canada in 2005 to that in 2006?
Ensure brevity in your answer.  1.04. What is the ratio of the Unemployed and educated female labor force (% of population) in Czech Republic in 2005 to that in 2006?
Keep it short and to the point. 1.03. What is the ratio of the Unemployed and educated female labor force (% of population) of Mauritius in 2005 to that in 2006?
Provide a succinct answer. 0.8. What is the ratio of the Unemployed and educated female labor force (% of population) of Thailand in 2005 to that in 2006?
Offer a terse response. 1.11. What is the ratio of the Unemployed and educated female labor force (% of population) of Canada in 2005 to that in 2007?
Keep it short and to the point. 1.03. What is the ratio of the Unemployed and educated female labor force (% of population) of Czech Republic in 2005 to that in 2007?
Your answer should be compact. 1.04. What is the ratio of the Unemployed and educated female labor force (% of population) in Mauritius in 2005 to that in 2007?
Make the answer very short. 0.85. What is the ratio of the Unemployed and educated female labor force (% of population) of Thailand in 2005 to that in 2007?
Make the answer very short. 1.12. What is the ratio of the Unemployed and educated female labor force (% of population) in Canada in 2005 to that in 2008?
Offer a terse response. 1.03. What is the ratio of the Unemployed and educated female labor force (% of population) in Czech Republic in 2005 to that in 2008?
Provide a succinct answer. 1.11. What is the ratio of the Unemployed and educated female labor force (% of population) in Mauritius in 2005 to that in 2008?
Your response must be concise. 0.85. What is the ratio of the Unemployed and educated female labor force (% of population) of Thailand in 2005 to that in 2008?
Ensure brevity in your answer.  2.87. What is the ratio of the Unemployed and educated female labor force (% of population) of Canada in 2005 to that in 2009?
Provide a succinct answer. 0.99. What is the ratio of the Unemployed and educated female labor force (% of population) of Czech Republic in 2005 to that in 2009?
Keep it short and to the point. 1.03. What is the ratio of the Unemployed and educated female labor force (% of population) of Mauritius in 2005 to that in 2009?
Provide a short and direct response. 1.44. What is the ratio of the Unemployed and educated female labor force (% of population) in Thailand in 2005 to that in 2009?
Offer a terse response. 2.68. What is the ratio of the Unemployed and educated female labor force (% of population) in Canada in 2005 to that in 2010?
Provide a succinct answer. 1.02. What is the ratio of the Unemployed and educated female labor force (% of population) in Czech Republic in 2005 to that in 2010?
Keep it short and to the point. 1.01. What is the ratio of the Unemployed and educated female labor force (% of population) of Mauritius in 2005 to that in 2010?
Provide a short and direct response. 1.41. What is the ratio of the Unemployed and educated female labor force (% of population) of Thailand in 2005 to that in 2010?
Keep it short and to the point. 2.98. What is the ratio of the Unemployed and educated female labor force (% of population) of Canada in 2005 to that in 2012?
Your answer should be very brief. 1.07. What is the ratio of the Unemployed and educated female labor force (% of population) of Czech Republic in 2005 to that in 2012?
Ensure brevity in your answer.  1.05. What is the ratio of the Unemployed and educated female labor force (% of population) in Mauritius in 2005 to that in 2012?
Your answer should be compact. 1.79. What is the ratio of the Unemployed and educated female labor force (% of population) in Thailand in 2005 to that in 2012?
Provide a succinct answer. 2.67. What is the ratio of the Unemployed and educated female labor force (% of population) in Czech Republic in 2006 to that in 2007?
Your response must be concise. 1.01. What is the ratio of the Unemployed and educated female labor force (% of population) in Mauritius in 2006 to that in 2007?
Keep it short and to the point. 1.06. What is the ratio of the Unemployed and educated female labor force (% of population) in Thailand in 2006 to that in 2007?
Your answer should be very brief. 1.01. What is the ratio of the Unemployed and educated female labor force (% of population) of Canada in 2006 to that in 2008?
Your answer should be very brief. 0.99. What is the ratio of the Unemployed and educated female labor force (% of population) of Czech Republic in 2006 to that in 2008?
Give a very brief answer. 1.09. What is the ratio of the Unemployed and educated female labor force (% of population) in Mauritius in 2006 to that in 2008?
Offer a very short reply. 1.06. What is the ratio of the Unemployed and educated female labor force (% of population) of Thailand in 2006 to that in 2008?
Make the answer very short. 2.59. What is the ratio of the Unemployed and educated female labor force (% of population) in Canada in 2006 to that in 2009?
Your response must be concise. 0.96. What is the ratio of the Unemployed and educated female labor force (% of population) of Mauritius in 2006 to that in 2009?
Give a very brief answer. 1.79. What is the ratio of the Unemployed and educated female labor force (% of population) in Thailand in 2006 to that in 2009?
Offer a terse response. 2.42. What is the ratio of the Unemployed and educated female labor force (% of population) in Canada in 2006 to that in 2010?
Your response must be concise. 0.98. What is the ratio of the Unemployed and educated female labor force (% of population) in Czech Republic in 2006 to that in 2010?
Offer a very short reply. 0.99. What is the ratio of the Unemployed and educated female labor force (% of population) in Mauritius in 2006 to that in 2010?
Your response must be concise. 1.75. What is the ratio of the Unemployed and educated female labor force (% of population) of Thailand in 2006 to that in 2010?
Provide a succinct answer. 2.69. What is the ratio of the Unemployed and educated female labor force (% of population) of Canada in 2006 to that in 2012?
Keep it short and to the point. 1.03. What is the ratio of the Unemployed and educated female labor force (% of population) of Czech Republic in 2006 to that in 2012?
Your response must be concise. 1.02. What is the ratio of the Unemployed and educated female labor force (% of population) in Mauritius in 2006 to that in 2012?
Provide a succinct answer. 2.23. What is the ratio of the Unemployed and educated female labor force (% of population) of Thailand in 2006 to that in 2012?
Keep it short and to the point. 2.41. What is the ratio of the Unemployed and educated female labor force (% of population) of Czech Republic in 2007 to that in 2008?
Provide a short and direct response. 1.07. What is the ratio of the Unemployed and educated female labor force (% of population) in Thailand in 2007 to that in 2008?
Your response must be concise. 2.57. What is the ratio of the Unemployed and educated female labor force (% of population) of Canada in 2007 to that in 2009?
Offer a very short reply. 0.96. What is the ratio of the Unemployed and educated female labor force (% of population) in Czech Republic in 2007 to that in 2009?
Ensure brevity in your answer.  0.99. What is the ratio of the Unemployed and educated female labor force (% of population) of Mauritius in 2007 to that in 2009?
Give a very brief answer. 1.69. What is the ratio of the Unemployed and educated female labor force (% of population) in Thailand in 2007 to that in 2009?
Your answer should be very brief. 2.4. What is the ratio of the Unemployed and educated female labor force (% of population) in Canada in 2007 to that in 2010?
Your response must be concise. 0.99. What is the ratio of the Unemployed and educated female labor force (% of population) of Czech Republic in 2007 to that in 2010?
Give a very brief answer. 0.97. What is the ratio of the Unemployed and educated female labor force (% of population) of Mauritius in 2007 to that in 2010?
Your answer should be compact. 1.65. What is the ratio of the Unemployed and educated female labor force (% of population) of Thailand in 2007 to that in 2010?
Provide a short and direct response. 2.67. What is the ratio of the Unemployed and educated female labor force (% of population) in Canada in 2007 to that in 2012?
Your answer should be very brief. 1.04. What is the ratio of the Unemployed and educated female labor force (% of population) in Czech Republic in 2007 to that in 2012?
Give a very brief answer. 1.01. What is the ratio of the Unemployed and educated female labor force (% of population) in Mauritius in 2007 to that in 2012?
Your answer should be compact. 2.1. What is the ratio of the Unemployed and educated female labor force (% of population) in Thailand in 2007 to that in 2012?
Make the answer very short. 2.39. What is the ratio of the Unemployed and educated female labor force (% of population) of Czech Republic in 2008 to that in 2009?
Make the answer very short. 0.92. What is the ratio of the Unemployed and educated female labor force (% of population) of Mauritius in 2008 to that in 2009?
Provide a short and direct response. 1.69. What is the ratio of the Unemployed and educated female labor force (% of population) of Thailand in 2008 to that in 2009?
Keep it short and to the point. 0.94. What is the ratio of the Unemployed and educated female labor force (% of population) in Czech Republic in 2008 to that in 2010?
Your answer should be compact. 0.91. What is the ratio of the Unemployed and educated female labor force (% of population) in Mauritius in 2008 to that in 2010?
Ensure brevity in your answer.  1.65. What is the ratio of the Unemployed and educated female labor force (% of population) in Thailand in 2008 to that in 2010?
Offer a very short reply. 1.04. What is the ratio of the Unemployed and educated female labor force (% of population) of Canada in 2008 to that in 2012?
Your response must be concise. 1.04. What is the ratio of the Unemployed and educated female labor force (% of population) of Czech Republic in 2008 to that in 2012?
Give a very brief answer. 0.94. What is the ratio of the Unemployed and educated female labor force (% of population) of Mauritius in 2008 to that in 2012?
Offer a terse response. 2.1. What is the ratio of the Unemployed and educated female labor force (% of population) of Thailand in 2008 to that in 2012?
Offer a very short reply. 0.93. What is the ratio of the Unemployed and educated female labor force (% of population) in Canada in 2009 to that in 2010?
Your answer should be compact. 1.03. What is the ratio of the Unemployed and educated female labor force (% of population) in Czech Republic in 2009 to that in 2010?
Offer a terse response. 0.99. What is the ratio of the Unemployed and educated female labor force (% of population) in Mauritius in 2009 to that in 2010?
Offer a very short reply. 0.98. What is the ratio of the Unemployed and educated female labor force (% of population) in Canada in 2009 to that in 2012?
Give a very brief answer. 1.08. What is the ratio of the Unemployed and educated female labor force (% of population) of Czech Republic in 2009 to that in 2012?
Your answer should be compact. 1.02. What is the ratio of the Unemployed and educated female labor force (% of population) of Mauritius in 2009 to that in 2012?
Provide a succinct answer. 1.25. What is the ratio of the Unemployed and educated female labor force (% of population) of Canada in 2010 to that in 2012?
Ensure brevity in your answer.  1.05. What is the ratio of the Unemployed and educated female labor force (% of population) of Czech Republic in 2010 to that in 2012?
Provide a succinct answer. 1.03. What is the ratio of the Unemployed and educated female labor force (% of population) in Mauritius in 2010 to that in 2012?
Make the answer very short. 1.27. What is the ratio of the Unemployed and educated female labor force (% of population) of Thailand in 2010 to that in 2012?
Your answer should be very brief. 0.9. What is the difference between the highest and the second highest Unemployed and educated female labor force (% of population) of Canada?
Offer a very short reply. 0.3. What is the difference between the highest and the second highest Unemployed and educated female labor force (% of population) in Czech Republic?
Ensure brevity in your answer.  0.9. What is the difference between the highest and the lowest Unemployed and educated female labor force (% of population) in Canada?
Keep it short and to the point. 3.1. What is the difference between the highest and the lowest Unemployed and educated female labor force (% of population) in Czech Republic?
Provide a short and direct response. 7.5. What is the difference between the highest and the lowest Unemployed and educated female labor force (% of population) of Mauritius?
Your answer should be very brief. 31.2. What is the difference between the highest and the lowest Unemployed and educated female labor force (% of population) of Thailand?
Your answer should be compact. 35.6. 